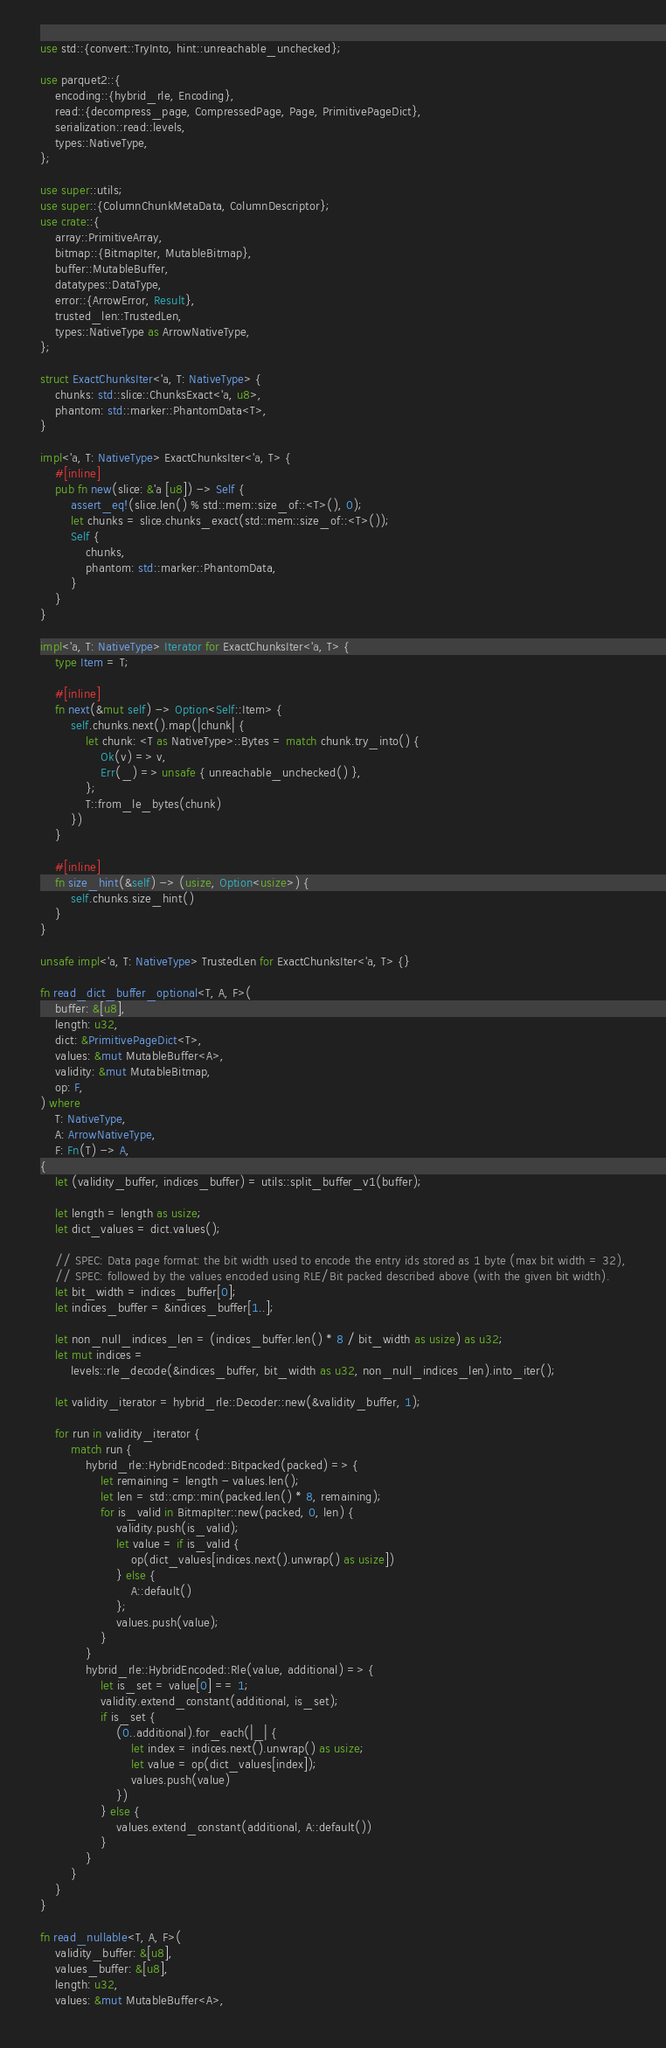<code> <loc_0><loc_0><loc_500><loc_500><_Rust_>use std::{convert::TryInto, hint::unreachable_unchecked};

use parquet2::{
    encoding::{hybrid_rle, Encoding},
    read::{decompress_page, CompressedPage, Page, PrimitivePageDict},
    serialization::read::levels,
    types::NativeType,
};

use super::utils;
use super::{ColumnChunkMetaData, ColumnDescriptor};
use crate::{
    array::PrimitiveArray,
    bitmap::{BitmapIter, MutableBitmap},
    buffer::MutableBuffer,
    datatypes::DataType,
    error::{ArrowError, Result},
    trusted_len::TrustedLen,
    types::NativeType as ArrowNativeType,
};

struct ExactChunksIter<'a, T: NativeType> {
    chunks: std::slice::ChunksExact<'a, u8>,
    phantom: std::marker::PhantomData<T>,
}

impl<'a, T: NativeType> ExactChunksIter<'a, T> {
    #[inline]
    pub fn new(slice: &'a [u8]) -> Self {
        assert_eq!(slice.len() % std::mem::size_of::<T>(), 0);
        let chunks = slice.chunks_exact(std::mem::size_of::<T>());
        Self {
            chunks,
            phantom: std::marker::PhantomData,
        }
    }
}

impl<'a, T: NativeType> Iterator for ExactChunksIter<'a, T> {
    type Item = T;

    #[inline]
    fn next(&mut self) -> Option<Self::Item> {
        self.chunks.next().map(|chunk| {
            let chunk: <T as NativeType>::Bytes = match chunk.try_into() {
                Ok(v) => v,
                Err(_) => unsafe { unreachable_unchecked() },
            };
            T::from_le_bytes(chunk)
        })
    }

    #[inline]
    fn size_hint(&self) -> (usize, Option<usize>) {
        self.chunks.size_hint()
    }
}

unsafe impl<'a, T: NativeType> TrustedLen for ExactChunksIter<'a, T> {}

fn read_dict_buffer_optional<T, A, F>(
    buffer: &[u8],
    length: u32,
    dict: &PrimitivePageDict<T>,
    values: &mut MutableBuffer<A>,
    validity: &mut MutableBitmap,
    op: F,
) where
    T: NativeType,
    A: ArrowNativeType,
    F: Fn(T) -> A,
{
    let (validity_buffer, indices_buffer) = utils::split_buffer_v1(buffer);

    let length = length as usize;
    let dict_values = dict.values();

    // SPEC: Data page format: the bit width used to encode the entry ids stored as 1 byte (max bit width = 32),
    // SPEC: followed by the values encoded using RLE/Bit packed described above (with the given bit width).
    let bit_width = indices_buffer[0];
    let indices_buffer = &indices_buffer[1..];

    let non_null_indices_len = (indices_buffer.len() * 8 / bit_width as usize) as u32;
    let mut indices =
        levels::rle_decode(&indices_buffer, bit_width as u32, non_null_indices_len).into_iter();

    let validity_iterator = hybrid_rle::Decoder::new(&validity_buffer, 1);

    for run in validity_iterator {
        match run {
            hybrid_rle::HybridEncoded::Bitpacked(packed) => {
                let remaining = length - values.len();
                let len = std::cmp::min(packed.len() * 8, remaining);
                for is_valid in BitmapIter::new(packed, 0, len) {
                    validity.push(is_valid);
                    let value = if is_valid {
                        op(dict_values[indices.next().unwrap() as usize])
                    } else {
                        A::default()
                    };
                    values.push(value);
                }
            }
            hybrid_rle::HybridEncoded::Rle(value, additional) => {
                let is_set = value[0] == 1;
                validity.extend_constant(additional, is_set);
                if is_set {
                    (0..additional).for_each(|_| {
                        let index = indices.next().unwrap() as usize;
                        let value = op(dict_values[index]);
                        values.push(value)
                    })
                } else {
                    values.extend_constant(additional, A::default())
                }
            }
        }
    }
}

fn read_nullable<T, A, F>(
    validity_buffer: &[u8],
    values_buffer: &[u8],
    length: u32,
    values: &mut MutableBuffer<A>,</code> 